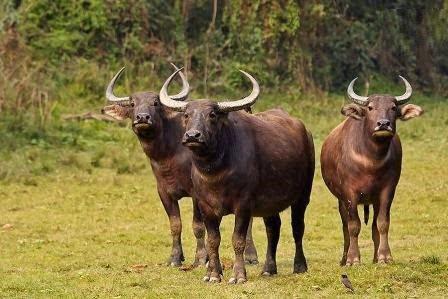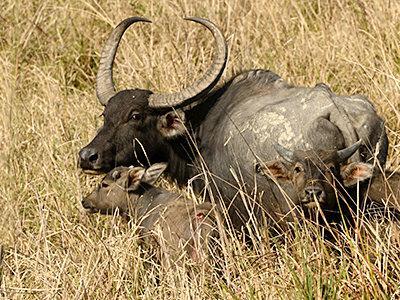The first image is the image on the left, the second image is the image on the right. For the images shown, is this caption "One of the images contains at least three water buffalo." true? Answer yes or no. Yes. The first image is the image on the left, the second image is the image on the right. Evaluate the accuracy of this statement regarding the images: "There is exactly one animal in the image on the right.". Is it true? Answer yes or no. No. 